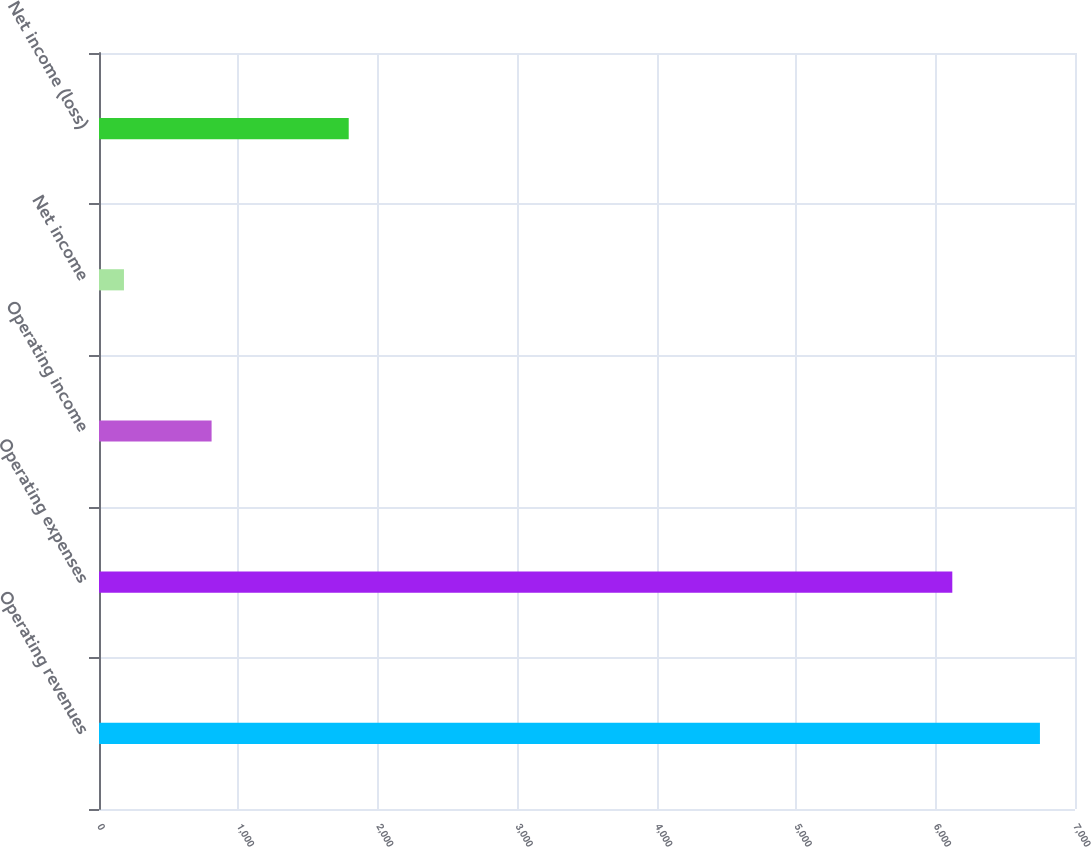<chart> <loc_0><loc_0><loc_500><loc_500><bar_chart><fcel>Operating revenues<fcel>Operating expenses<fcel>Operating income<fcel>Net income<fcel>Net income (loss)<nl><fcel>6748.5<fcel>6120<fcel>807.5<fcel>179<fcel>1791<nl></chart> 